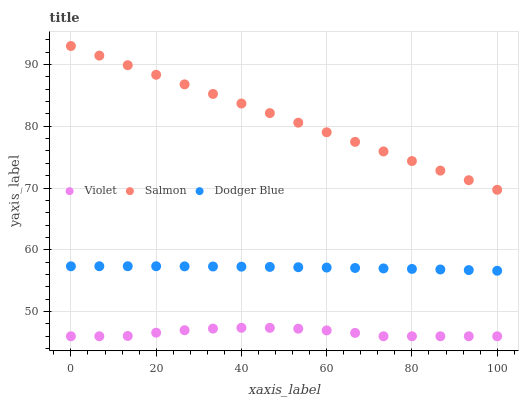Does Violet have the minimum area under the curve?
Answer yes or no. Yes. Does Salmon have the maximum area under the curve?
Answer yes or no. Yes. Does Salmon have the minimum area under the curve?
Answer yes or no. No. Does Violet have the maximum area under the curve?
Answer yes or no. No. Is Salmon the smoothest?
Answer yes or no. Yes. Is Violet the roughest?
Answer yes or no. Yes. Is Violet the smoothest?
Answer yes or no. No. Is Salmon the roughest?
Answer yes or no. No. Does Violet have the lowest value?
Answer yes or no. Yes. Does Salmon have the lowest value?
Answer yes or no. No. Does Salmon have the highest value?
Answer yes or no. Yes. Does Violet have the highest value?
Answer yes or no. No. Is Violet less than Salmon?
Answer yes or no. Yes. Is Salmon greater than Violet?
Answer yes or no. Yes. Does Violet intersect Salmon?
Answer yes or no. No. 